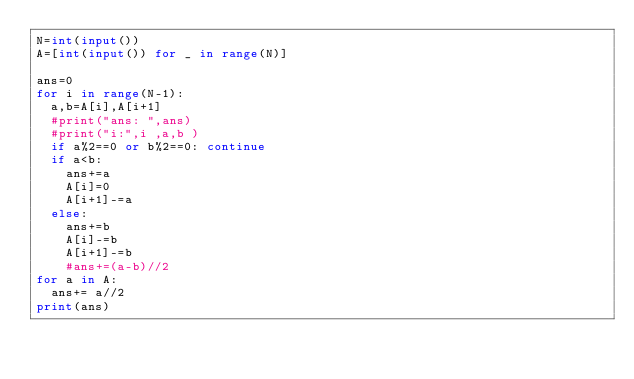Convert code to text. <code><loc_0><loc_0><loc_500><loc_500><_Python_>N=int(input())
A=[int(input()) for _ in range(N)]
 
ans=0
for i in range(N-1):
  a,b=A[i],A[i+1] 
  #print("ans: ",ans)
  #print("i:",i ,a,b ) 
  if a%2==0 or b%2==0: continue
  if a<b: 
    ans+=a
    A[i]=0
    A[i+1]-=a
  else:
    ans+=b
    A[i]-=b
    A[i+1]-=b
    #ans+=(a-b)//2
for a in A:
  ans+= a//2
print(ans)
</code> 